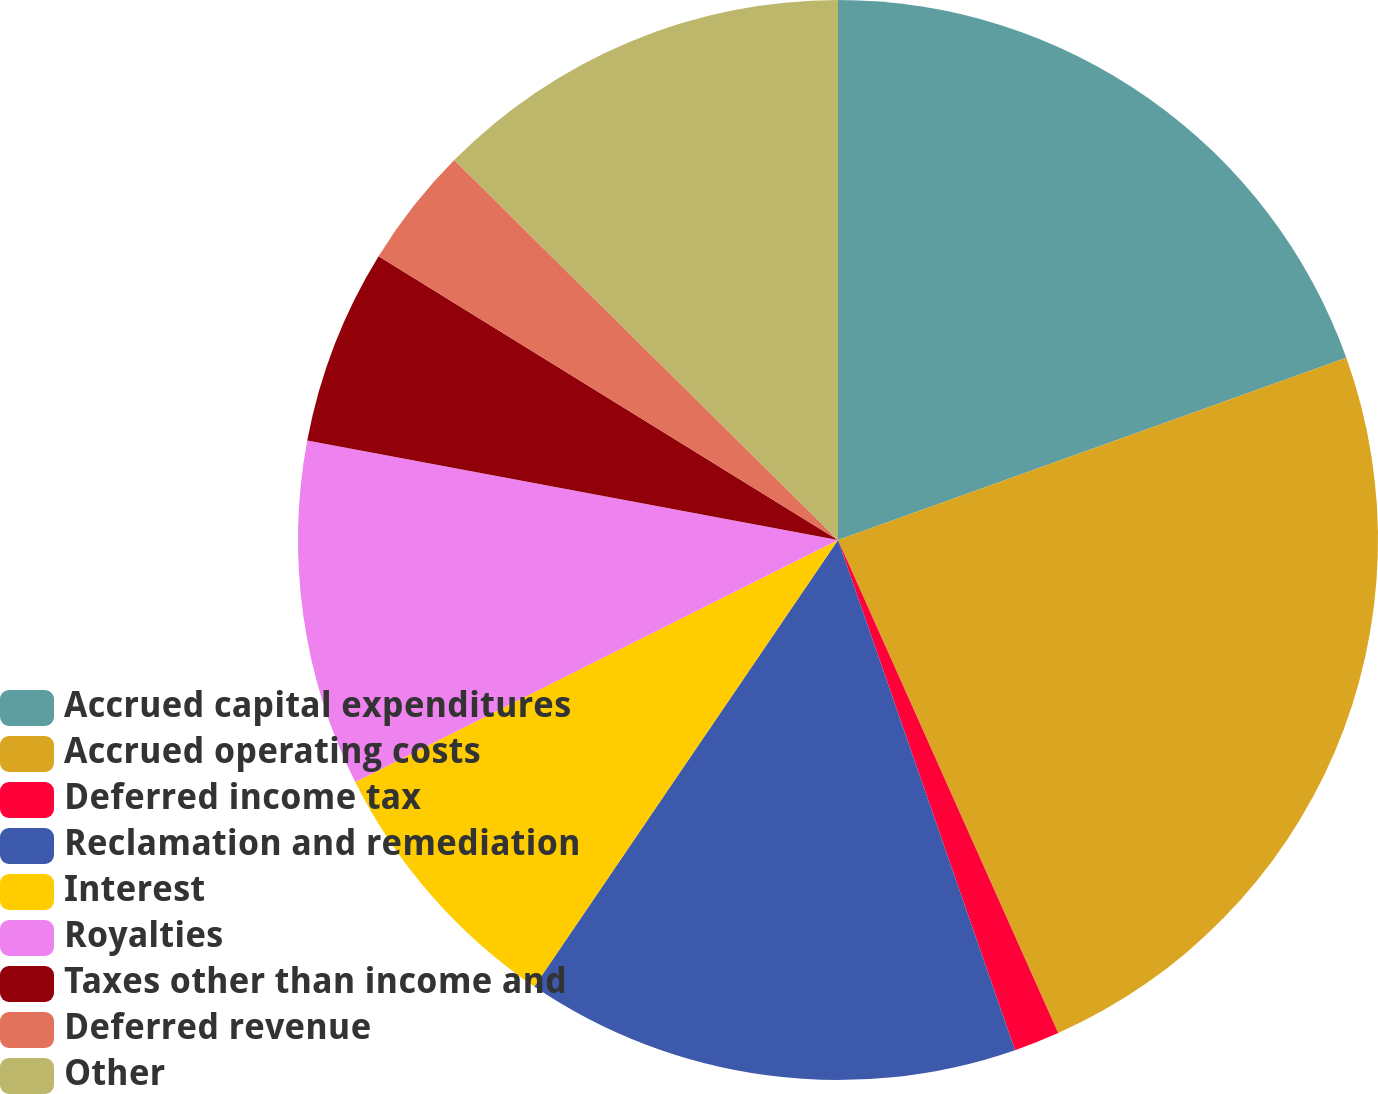<chart> <loc_0><loc_0><loc_500><loc_500><pie_chart><fcel>Accrued capital expenditures<fcel>Accrued operating costs<fcel>Deferred income tax<fcel>Reclamation and remediation<fcel>Interest<fcel>Royalties<fcel>Taxes other than income and<fcel>Deferred revenue<fcel>Other<nl><fcel>19.52%<fcel>23.79%<fcel>1.37%<fcel>14.82%<fcel>8.1%<fcel>10.34%<fcel>5.86%<fcel>3.61%<fcel>12.58%<nl></chart> 